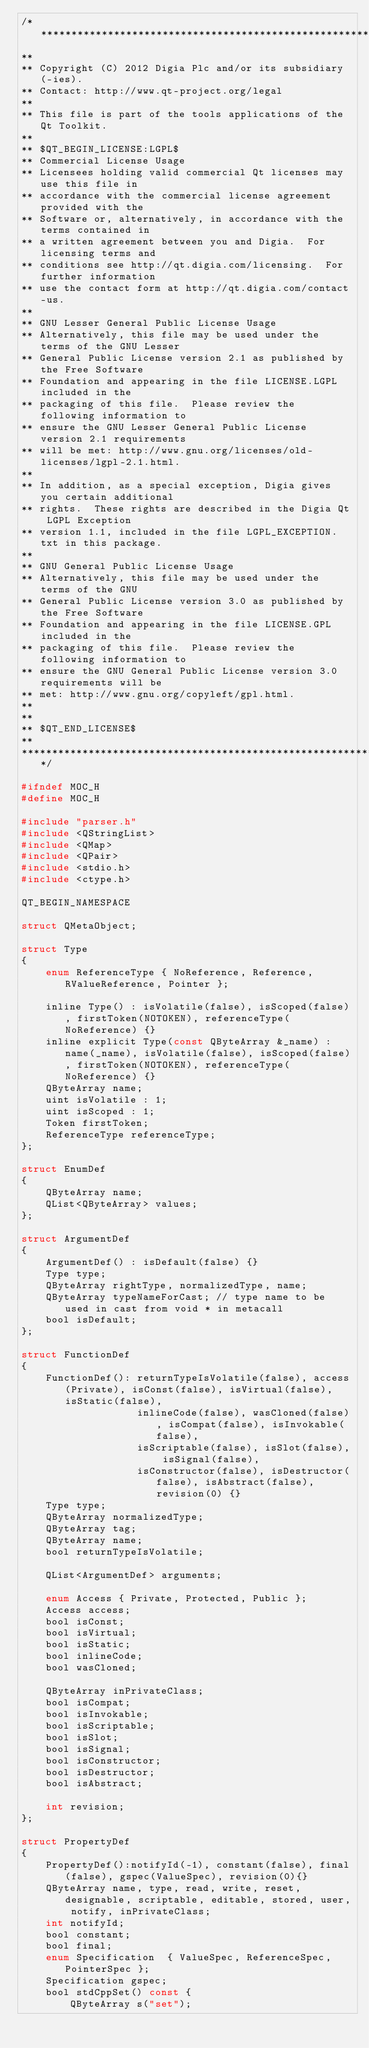Convert code to text. <code><loc_0><loc_0><loc_500><loc_500><_C_>/****************************************************************************
**
** Copyright (C) 2012 Digia Plc and/or its subsidiary(-ies).
** Contact: http://www.qt-project.org/legal
**
** This file is part of the tools applications of the Qt Toolkit.
**
** $QT_BEGIN_LICENSE:LGPL$
** Commercial License Usage
** Licensees holding valid commercial Qt licenses may use this file in
** accordance with the commercial license agreement provided with the
** Software or, alternatively, in accordance with the terms contained in
** a written agreement between you and Digia.  For licensing terms and
** conditions see http://qt.digia.com/licensing.  For further information
** use the contact form at http://qt.digia.com/contact-us.
**
** GNU Lesser General Public License Usage
** Alternatively, this file may be used under the terms of the GNU Lesser
** General Public License version 2.1 as published by the Free Software
** Foundation and appearing in the file LICENSE.LGPL included in the
** packaging of this file.  Please review the following information to
** ensure the GNU Lesser General Public License version 2.1 requirements
** will be met: http://www.gnu.org/licenses/old-licenses/lgpl-2.1.html.
**
** In addition, as a special exception, Digia gives you certain additional
** rights.  These rights are described in the Digia Qt LGPL Exception
** version 1.1, included in the file LGPL_EXCEPTION.txt in this package.
**
** GNU General Public License Usage
** Alternatively, this file may be used under the terms of the GNU
** General Public License version 3.0 as published by the Free Software
** Foundation and appearing in the file LICENSE.GPL included in the
** packaging of this file.  Please review the following information to
** ensure the GNU General Public License version 3.0 requirements will be
** met: http://www.gnu.org/copyleft/gpl.html.
**
**
** $QT_END_LICENSE$
**
****************************************************************************/

#ifndef MOC_H
#define MOC_H

#include "parser.h"
#include <QStringList>
#include <QMap>
#include <QPair>
#include <stdio.h>
#include <ctype.h>

QT_BEGIN_NAMESPACE

struct QMetaObject;

struct Type
{
    enum ReferenceType { NoReference, Reference, RValueReference, Pointer };

    inline Type() : isVolatile(false), isScoped(false), firstToken(NOTOKEN), referenceType(NoReference) {}
    inline explicit Type(const QByteArray &_name) : name(_name), isVolatile(false), isScoped(false), firstToken(NOTOKEN), referenceType(NoReference) {}
    QByteArray name;
    uint isVolatile : 1;
    uint isScoped : 1;
    Token firstToken;
    ReferenceType referenceType;
};

struct EnumDef
{
    QByteArray name;
    QList<QByteArray> values;
};

struct ArgumentDef
{
    ArgumentDef() : isDefault(false) {}
    Type type;
    QByteArray rightType, normalizedType, name;
    QByteArray typeNameForCast; // type name to be used in cast from void * in metacall
    bool isDefault;
};

struct FunctionDef
{
    FunctionDef(): returnTypeIsVolatile(false), access(Private), isConst(false), isVirtual(false), isStatic(false),
                   inlineCode(false), wasCloned(false), isCompat(false), isInvokable(false),
                   isScriptable(false), isSlot(false), isSignal(false),
                   isConstructor(false), isDestructor(false), isAbstract(false), revision(0) {}
    Type type;
    QByteArray normalizedType;
    QByteArray tag;
    QByteArray name;
    bool returnTypeIsVolatile;

    QList<ArgumentDef> arguments;

    enum Access { Private, Protected, Public };
    Access access;
    bool isConst;
    bool isVirtual;
    bool isStatic;
    bool inlineCode;
    bool wasCloned;

    QByteArray inPrivateClass;
    bool isCompat;
    bool isInvokable;
    bool isScriptable;
    bool isSlot;
    bool isSignal;
    bool isConstructor;
    bool isDestructor;
    bool isAbstract;

    int revision;
};

struct PropertyDef
{
    PropertyDef():notifyId(-1), constant(false), final(false), gspec(ValueSpec), revision(0){}
    QByteArray name, type, read, write, reset, designable, scriptable, editable, stored, user, notify, inPrivateClass;
    int notifyId;
    bool constant;
    bool final;
    enum Specification  { ValueSpec, ReferenceSpec, PointerSpec };
    Specification gspec;
    bool stdCppSet() const {
        QByteArray s("set");</code> 